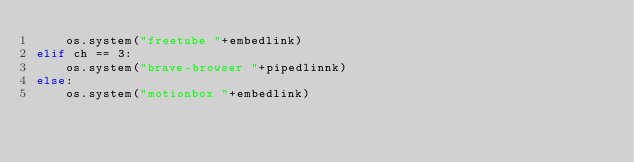<code> <loc_0><loc_0><loc_500><loc_500><_Python_>	os.system("freetube "+embedlink)
elif ch == 3:
	os.system("brave-browser "+pipedlinnk)
else:
	os.system("motionbox "+embedlink)
</code> 